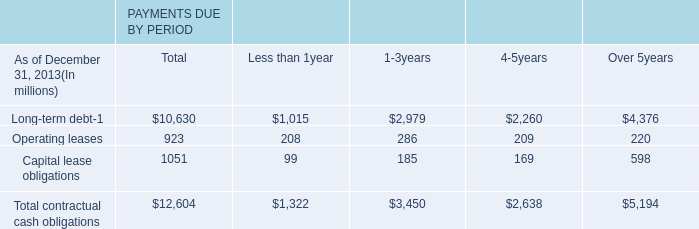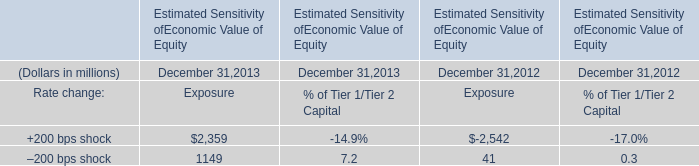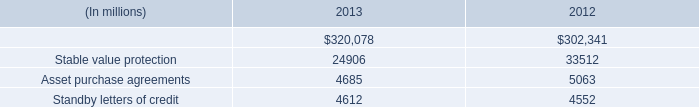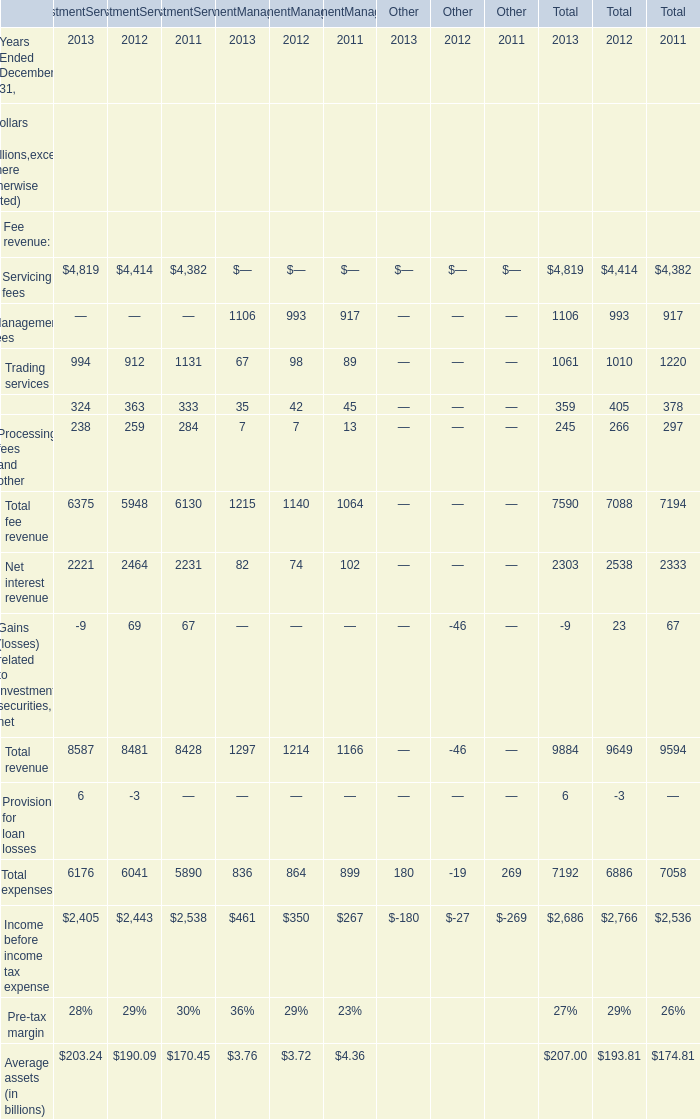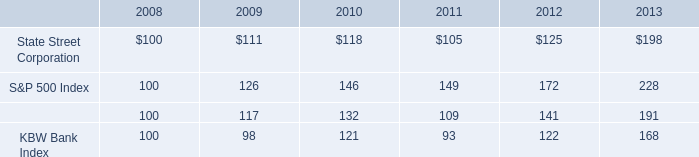what is the roi of an investment in kbw bank index from 2008 to 2011? 
Computations: ((93 - 100) / 100)
Answer: -0.07. 